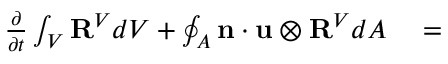<formula> <loc_0><loc_0><loc_500><loc_500>\begin{array} { r l } { \frac { \partial } { \partial t } \int _ { V } R ^ { V } d V + \oint _ { A } n \cdot u \otimes R ^ { V } d A } & = } \end{array}</formula> 